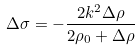<formula> <loc_0><loc_0><loc_500><loc_500>\Delta \sigma = - \frac { 2 k ^ { 2 } \Delta \rho } { 2 \rho _ { 0 } + \Delta \rho }</formula> 